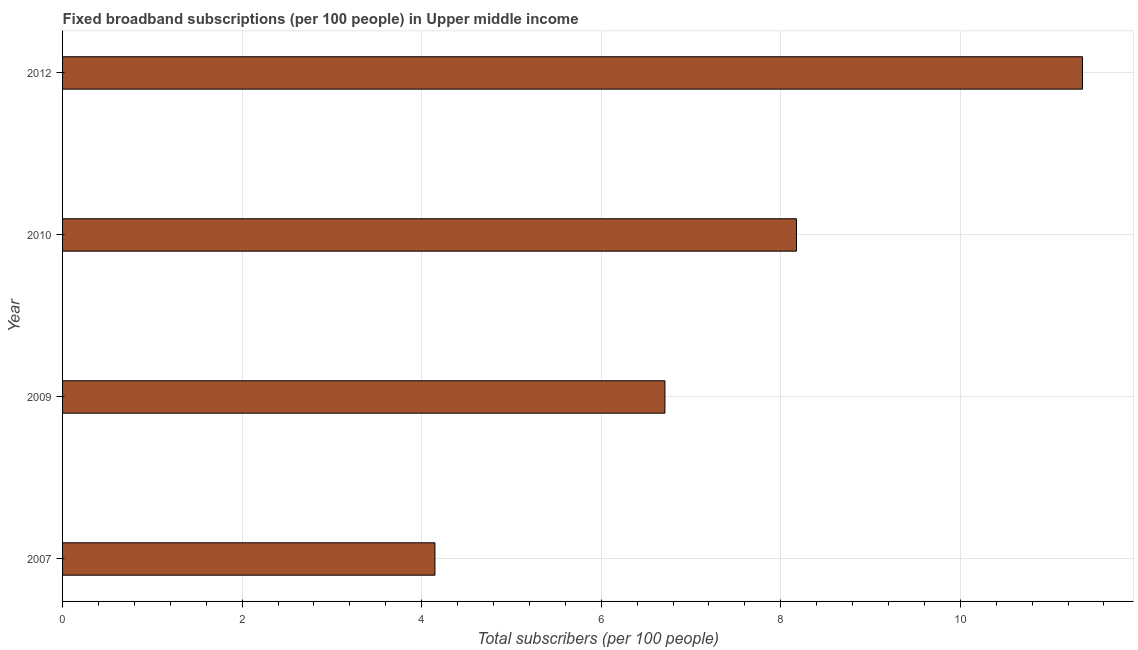What is the title of the graph?
Make the answer very short. Fixed broadband subscriptions (per 100 people) in Upper middle income. What is the label or title of the X-axis?
Provide a succinct answer. Total subscribers (per 100 people). What is the total number of fixed broadband subscriptions in 2007?
Offer a very short reply. 4.15. Across all years, what is the maximum total number of fixed broadband subscriptions?
Your answer should be very brief. 11.36. Across all years, what is the minimum total number of fixed broadband subscriptions?
Keep it short and to the point. 4.15. In which year was the total number of fixed broadband subscriptions minimum?
Provide a short and direct response. 2007. What is the sum of the total number of fixed broadband subscriptions?
Keep it short and to the point. 30.39. What is the difference between the total number of fixed broadband subscriptions in 2007 and 2009?
Your answer should be compact. -2.56. What is the average total number of fixed broadband subscriptions per year?
Your response must be concise. 7.6. What is the median total number of fixed broadband subscriptions?
Provide a short and direct response. 7.44. What is the ratio of the total number of fixed broadband subscriptions in 2009 to that in 2012?
Make the answer very short. 0.59. What is the difference between the highest and the second highest total number of fixed broadband subscriptions?
Offer a very short reply. 3.19. What is the difference between the highest and the lowest total number of fixed broadband subscriptions?
Your response must be concise. 7.21. In how many years, is the total number of fixed broadband subscriptions greater than the average total number of fixed broadband subscriptions taken over all years?
Provide a succinct answer. 2. How many years are there in the graph?
Keep it short and to the point. 4. What is the Total subscribers (per 100 people) in 2007?
Provide a short and direct response. 4.15. What is the Total subscribers (per 100 people) in 2009?
Your answer should be compact. 6.71. What is the Total subscribers (per 100 people) in 2010?
Give a very brief answer. 8.17. What is the Total subscribers (per 100 people) in 2012?
Keep it short and to the point. 11.36. What is the difference between the Total subscribers (per 100 people) in 2007 and 2009?
Give a very brief answer. -2.56. What is the difference between the Total subscribers (per 100 people) in 2007 and 2010?
Provide a short and direct response. -4.03. What is the difference between the Total subscribers (per 100 people) in 2007 and 2012?
Provide a short and direct response. -7.21. What is the difference between the Total subscribers (per 100 people) in 2009 and 2010?
Offer a very short reply. -1.47. What is the difference between the Total subscribers (per 100 people) in 2009 and 2012?
Provide a short and direct response. -4.65. What is the difference between the Total subscribers (per 100 people) in 2010 and 2012?
Your answer should be compact. -3.19. What is the ratio of the Total subscribers (per 100 people) in 2007 to that in 2009?
Make the answer very short. 0.62. What is the ratio of the Total subscribers (per 100 people) in 2007 to that in 2010?
Your response must be concise. 0.51. What is the ratio of the Total subscribers (per 100 people) in 2007 to that in 2012?
Your answer should be very brief. 0.36. What is the ratio of the Total subscribers (per 100 people) in 2009 to that in 2010?
Your response must be concise. 0.82. What is the ratio of the Total subscribers (per 100 people) in 2009 to that in 2012?
Your response must be concise. 0.59. What is the ratio of the Total subscribers (per 100 people) in 2010 to that in 2012?
Provide a succinct answer. 0.72. 